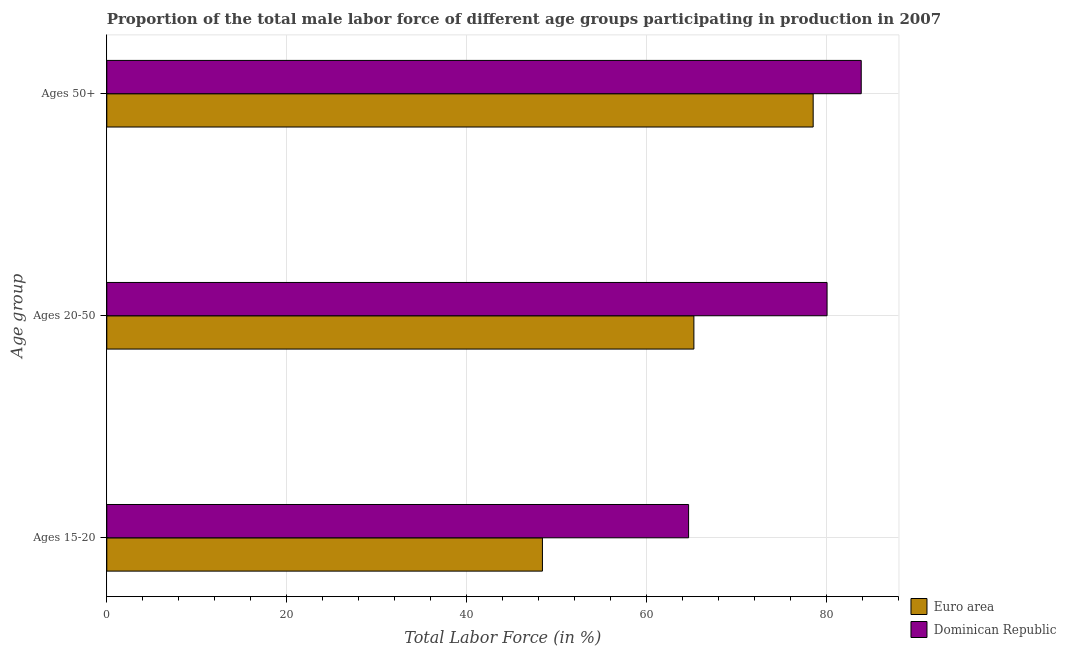Are the number of bars on each tick of the Y-axis equal?
Give a very brief answer. Yes. How many bars are there on the 1st tick from the bottom?
Your answer should be very brief. 2. What is the label of the 3rd group of bars from the top?
Keep it short and to the point. Ages 15-20. What is the percentage of male labor force within the age group 20-50 in Dominican Republic?
Make the answer very short. 80.1. Across all countries, what is the maximum percentage of male labor force within the age group 20-50?
Keep it short and to the point. 80.1. Across all countries, what is the minimum percentage of male labor force within the age group 20-50?
Provide a short and direct response. 65.29. In which country was the percentage of male labor force within the age group 15-20 maximum?
Your response must be concise. Dominican Republic. What is the total percentage of male labor force within the age group 20-50 in the graph?
Offer a terse response. 145.39. What is the difference between the percentage of male labor force above age 50 in Euro area and that in Dominican Republic?
Provide a succinct answer. -5.34. What is the difference between the percentage of male labor force within the age group 15-20 in Euro area and the percentage of male labor force within the age group 20-50 in Dominican Republic?
Ensure brevity in your answer.  -31.65. What is the average percentage of male labor force within the age group 15-20 per country?
Your response must be concise. 56.57. What is the difference between the percentage of male labor force above age 50 and percentage of male labor force within the age group 15-20 in Euro area?
Your response must be concise. 30.11. In how many countries, is the percentage of male labor force within the age group 15-20 greater than 36 %?
Offer a terse response. 2. What is the ratio of the percentage of male labor force within the age group 15-20 in Euro area to that in Dominican Republic?
Keep it short and to the point. 0.75. Is the percentage of male labor force within the age group 15-20 in Dominican Republic less than that in Euro area?
Provide a short and direct response. No. Is the difference between the percentage of male labor force above age 50 in Dominican Republic and Euro area greater than the difference between the percentage of male labor force within the age group 20-50 in Dominican Republic and Euro area?
Provide a succinct answer. No. What is the difference between the highest and the second highest percentage of male labor force within the age group 15-20?
Ensure brevity in your answer.  16.25. What is the difference between the highest and the lowest percentage of male labor force above age 50?
Keep it short and to the point. 5.34. In how many countries, is the percentage of male labor force within the age group 15-20 greater than the average percentage of male labor force within the age group 15-20 taken over all countries?
Your answer should be compact. 1. Is the sum of the percentage of male labor force within the age group 20-50 in Dominican Republic and Euro area greater than the maximum percentage of male labor force within the age group 15-20 across all countries?
Your answer should be very brief. Yes. What does the 1st bar from the top in Ages 20-50 represents?
Your answer should be very brief. Dominican Republic. What does the 1st bar from the bottom in Ages 20-50 represents?
Ensure brevity in your answer.  Euro area. How many countries are there in the graph?
Your response must be concise. 2. What is the difference between two consecutive major ticks on the X-axis?
Provide a succinct answer. 20. Does the graph contain grids?
Make the answer very short. Yes. Where does the legend appear in the graph?
Your answer should be compact. Bottom right. How are the legend labels stacked?
Make the answer very short. Vertical. What is the title of the graph?
Your answer should be compact. Proportion of the total male labor force of different age groups participating in production in 2007. Does "Nigeria" appear as one of the legend labels in the graph?
Your answer should be very brief. No. What is the label or title of the Y-axis?
Your response must be concise. Age group. What is the Total Labor Force (in %) of Euro area in Ages 15-20?
Give a very brief answer. 48.45. What is the Total Labor Force (in %) in Dominican Republic in Ages 15-20?
Offer a very short reply. 64.7. What is the Total Labor Force (in %) in Euro area in Ages 20-50?
Your answer should be very brief. 65.29. What is the Total Labor Force (in %) of Dominican Republic in Ages 20-50?
Offer a terse response. 80.1. What is the Total Labor Force (in %) in Euro area in Ages 50+?
Your answer should be very brief. 78.56. What is the Total Labor Force (in %) in Dominican Republic in Ages 50+?
Ensure brevity in your answer.  83.9. Across all Age group, what is the maximum Total Labor Force (in %) in Euro area?
Give a very brief answer. 78.56. Across all Age group, what is the maximum Total Labor Force (in %) of Dominican Republic?
Make the answer very short. 83.9. Across all Age group, what is the minimum Total Labor Force (in %) in Euro area?
Your answer should be compact. 48.45. Across all Age group, what is the minimum Total Labor Force (in %) of Dominican Republic?
Give a very brief answer. 64.7. What is the total Total Labor Force (in %) of Euro area in the graph?
Keep it short and to the point. 192.29. What is the total Total Labor Force (in %) in Dominican Republic in the graph?
Your answer should be very brief. 228.7. What is the difference between the Total Labor Force (in %) of Euro area in Ages 15-20 and that in Ages 20-50?
Offer a very short reply. -16.84. What is the difference between the Total Labor Force (in %) of Dominican Republic in Ages 15-20 and that in Ages 20-50?
Your response must be concise. -15.4. What is the difference between the Total Labor Force (in %) in Euro area in Ages 15-20 and that in Ages 50+?
Your answer should be very brief. -30.11. What is the difference between the Total Labor Force (in %) of Dominican Republic in Ages 15-20 and that in Ages 50+?
Keep it short and to the point. -19.2. What is the difference between the Total Labor Force (in %) of Euro area in Ages 20-50 and that in Ages 50+?
Provide a succinct answer. -13.27. What is the difference between the Total Labor Force (in %) in Euro area in Ages 15-20 and the Total Labor Force (in %) in Dominican Republic in Ages 20-50?
Provide a succinct answer. -31.65. What is the difference between the Total Labor Force (in %) in Euro area in Ages 15-20 and the Total Labor Force (in %) in Dominican Republic in Ages 50+?
Ensure brevity in your answer.  -35.45. What is the difference between the Total Labor Force (in %) in Euro area in Ages 20-50 and the Total Labor Force (in %) in Dominican Republic in Ages 50+?
Provide a succinct answer. -18.61. What is the average Total Labor Force (in %) of Euro area per Age group?
Offer a terse response. 64.1. What is the average Total Labor Force (in %) in Dominican Republic per Age group?
Offer a very short reply. 76.23. What is the difference between the Total Labor Force (in %) in Euro area and Total Labor Force (in %) in Dominican Republic in Ages 15-20?
Offer a very short reply. -16.25. What is the difference between the Total Labor Force (in %) of Euro area and Total Labor Force (in %) of Dominican Republic in Ages 20-50?
Ensure brevity in your answer.  -14.81. What is the difference between the Total Labor Force (in %) in Euro area and Total Labor Force (in %) in Dominican Republic in Ages 50+?
Make the answer very short. -5.34. What is the ratio of the Total Labor Force (in %) in Euro area in Ages 15-20 to that in Ages 20-50?
Give a very brief answer. 0.74. What is the ratio of the Total Labor Force (in %) in Dominican Republic in Ages 15-20 to that in Ages 20-50?
Keep it short and to the point. 0.81. What is the ratio of the Total Labor Force (in %) of Euro area in Ages 15-20 to that in Ages 50+?
Your answer should be compact. 0.62. What is the ratio of the Total Labor Force (in %) in Dominican Republic in Ages 15-20 to that in Ages 50+?
Ensure brevity in your answer.  0.77. What is the ratio of the Total Labor Force (in %) in Euro area in Ages 20-50 to that in Ages 50+?
Your response must be concise. 0.83. What is the ratio of the Total Labor Force (in %) in Dominican Republic in Ages 20-50 to that in Ages 50+?
Your answer should be very brief. 0.95. What is the difference between the highest and the second highest Total Labor Force (in %) of Euro area?
Keep it short and to the point. 13.27. What is the difference between the highest and the second highest Total Labor Force (in %) of Dominican Republic?
Provide a short and direct response. 3.8. What is the difference between the highest and the lowest Total Labor Force (in %) in Euro area?
Make the answer very short. 30.11. 